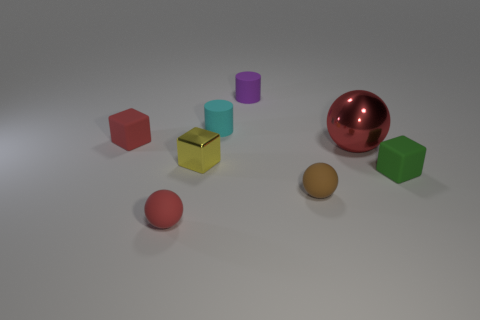Subtract all yellow balls. Subtract all purple cylinders. How many balls are left? 3 Subtract all yellow cylinders. How many brown spheres are left? 1 Add 7 large things. How many small reds exist? 0 Subtract all yellow matte cylinders. Subtract all rubber balls. How many objects are left? 6 Add 1 tiny rubber spheres. How many tiny rubber spheres are left? 3 Add 6 large cyan blocks. How many large cyan blocks exist? 6 Add 1 yellow metal balls. How many objects exist? 9 Subtract all brown balls. How many balls are left? 2 Subtract all small matte spheres. How many spheres are left? 1 Subtract 0 brown blocks. How many objects are left? 8 